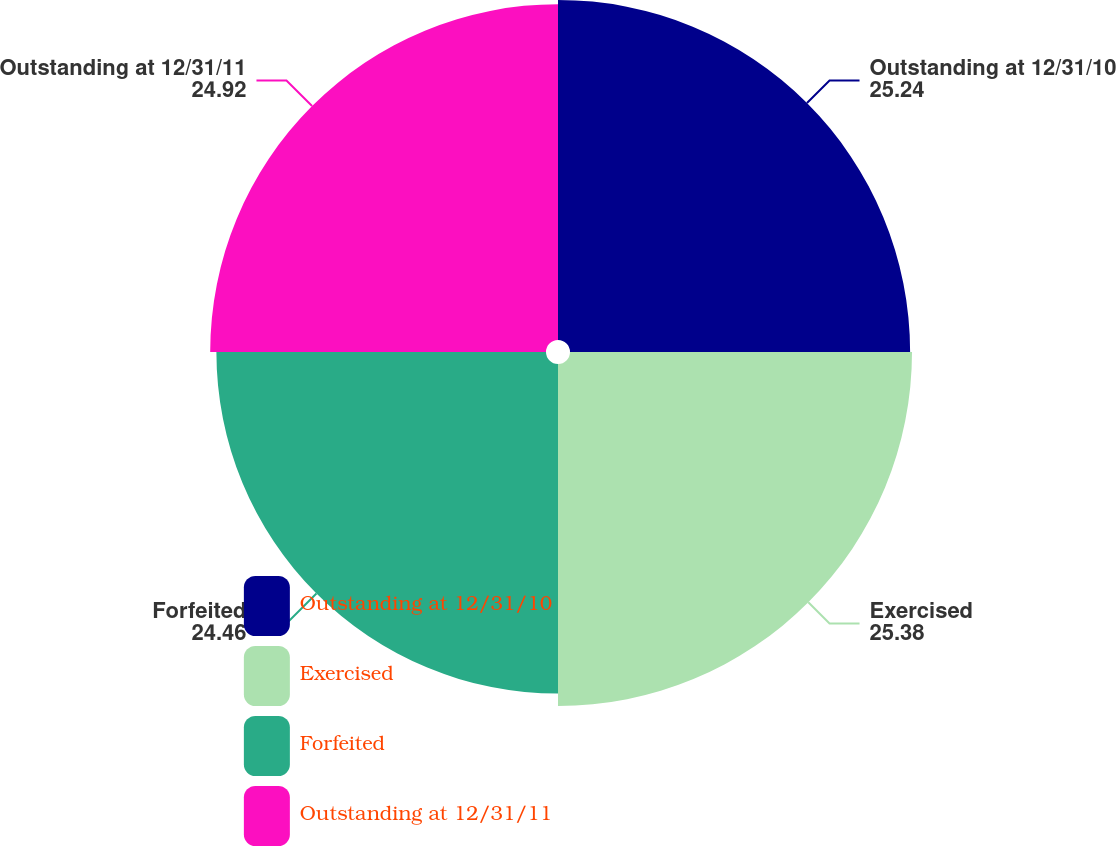<chart> <loc_0><loc_0><loc_500><loc_500><pie_chart><fcel>Outstanding at 12/31/10<fcel>Exercised<fcel>Forfeited<fcel>Outstanding at 12/31/11<nl><fcel>25.24%<fcel>25.38%<fcel>24.46%<fcel>24.92%<nl></chart> 